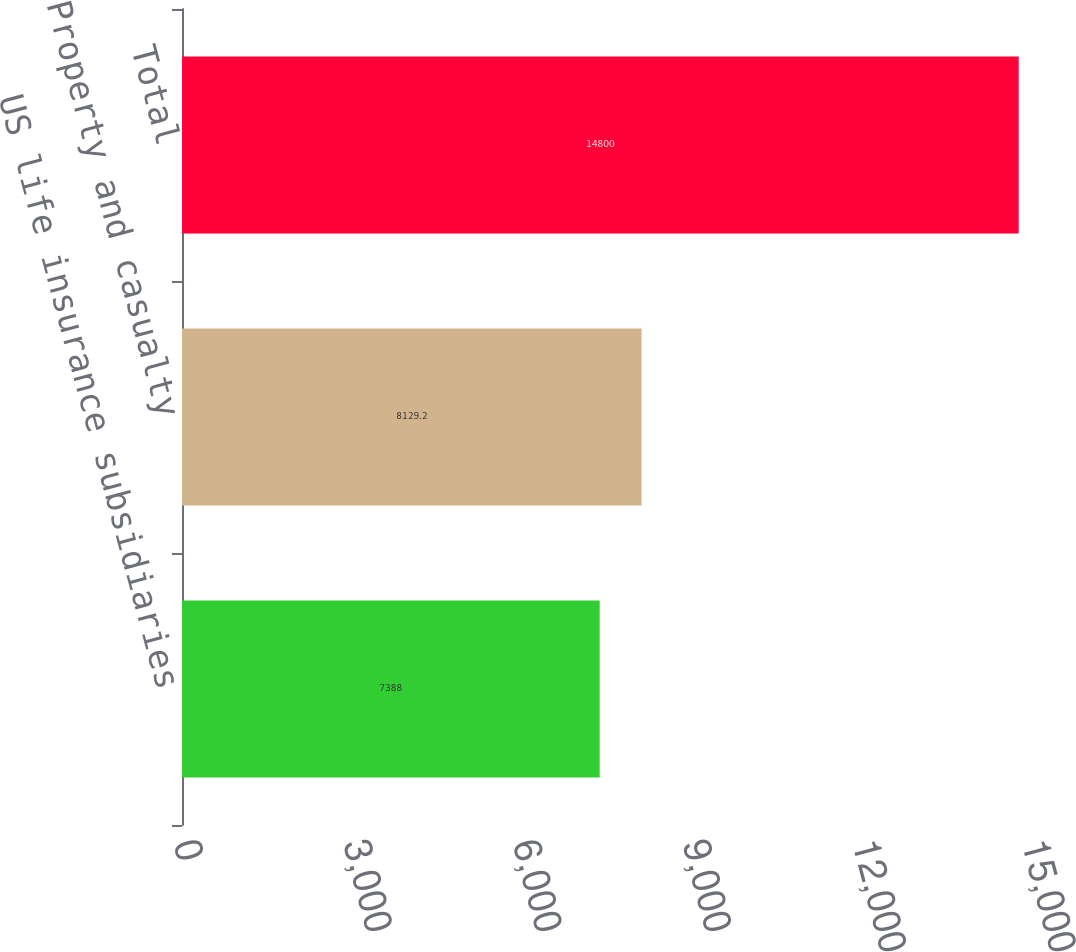<chart> <loc_0><loc_0><loc_500><loc_500><bar_chart><fcel>US life insurance subsidiaries<fcel>Property and casualty<fcel>Total<nl><fcel>7388<fcel>8129.2<fcel>14800<nl></chart> 